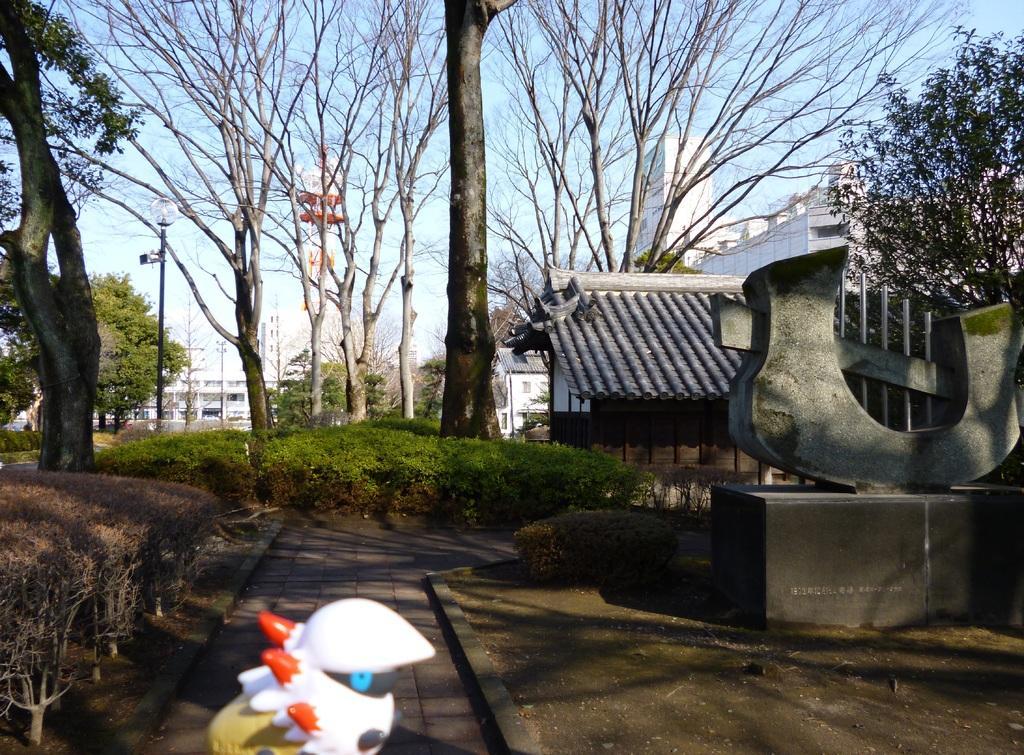How would you summarize this image in a sentence or two? In the center of the image we can see buildings, electric light pole, tower, trees, roof and some plants. On the right side of the image we can see a statue. At the bottom of the image we can see the ground and a toy. At the top of the image we can see the sky. 